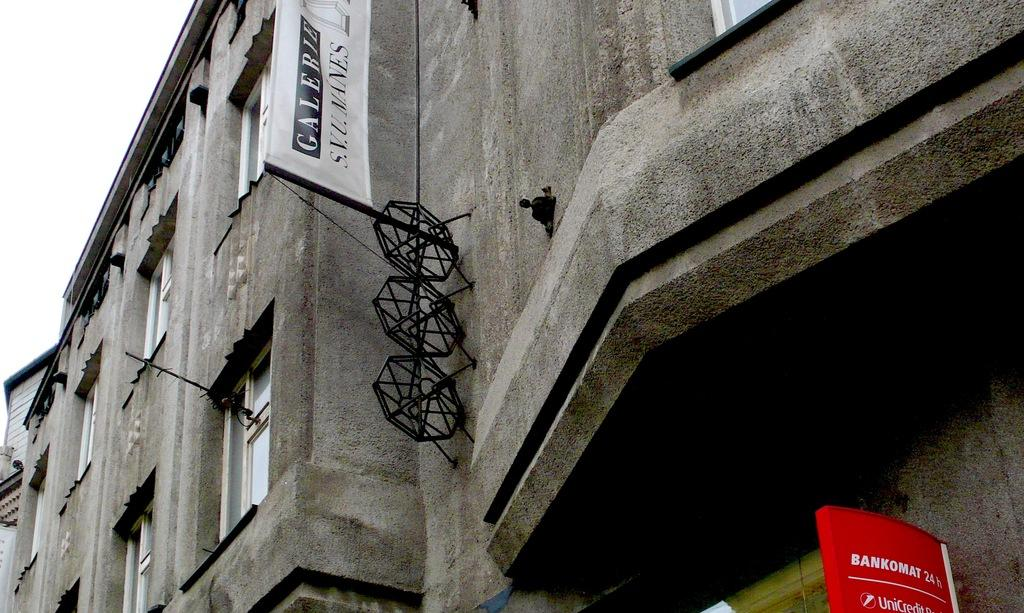What type of structure is present in the image? There is a building in the image. What can be seen in the background of the image? The sky is visible in the background of the image. What type of string is being used to hold up the surprise in the image? There is no surprise or string present in the image; it only features a building and the sky. 